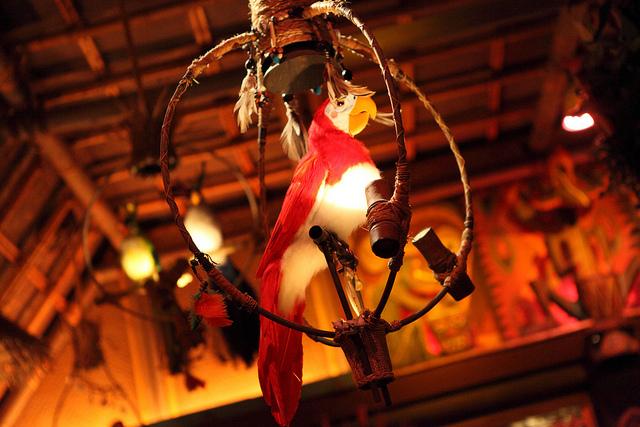Is there a bird on this perch?
Concise answer only. Yes. Is this a parrot?
Give a very brief answer. Yes. What is the perch made of?
Answer briefly. Wood. 